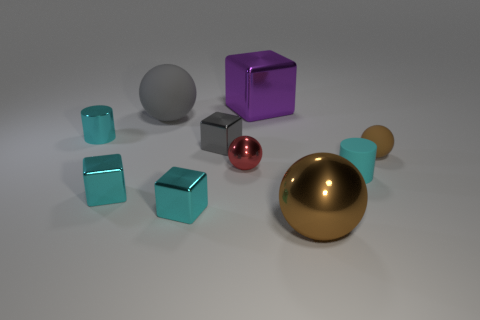How many tiny spheres are to the left of the tiny brown rubber object? To the left of the tiny brown rubber object, there is one small gray sphere. The arrangement positions the sphere as if it is slightly ahead and to the left, depending on your perspective. 